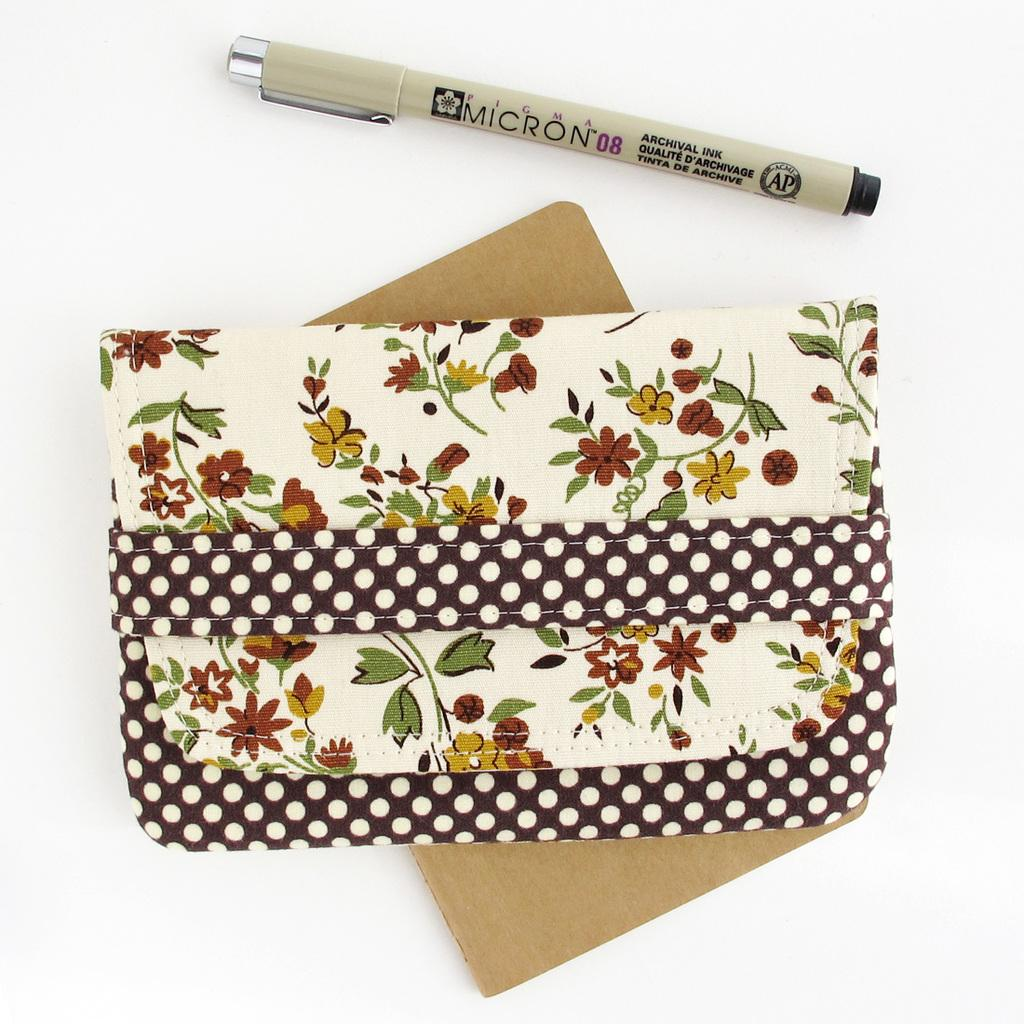What objects are in the foreground of the image? There is a pen, a cardboard piece, and a pouch-like object in the foreground of the image. What is the color of the surface on which these objects are placed? These objects are on a white surface. How many chickens can be seen in the image? There are no chickens present in the image. What type of rainstorm is depicted in the image? There is no rainstorm depicted in the image. 